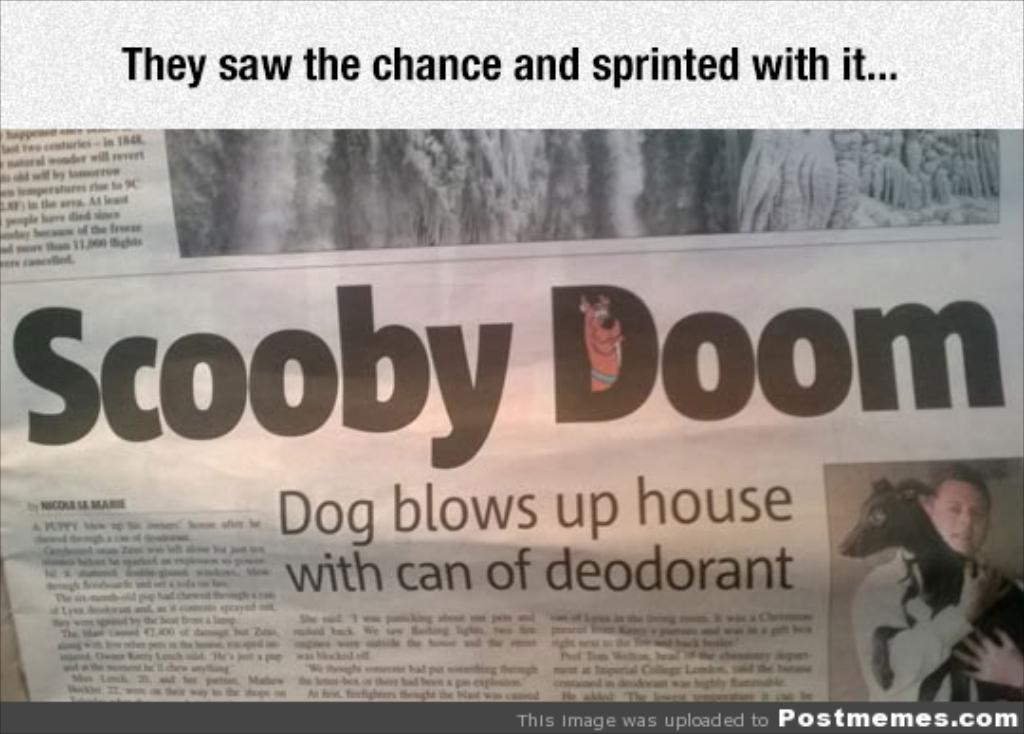What is the main subject in the center of the image? There is a newspaper in the center of the image. What is happening with the newspaper in the image? A person is holding a dog on the newspaper. Can you describe the newspaper in the image? There is writing on the newspaper. What type of chain can be seen connecting the dog to the newspaper? There is no chain present in the image; the dog is simply being held on the newspaper by a person. What stage of development is the beast currently in, as seen in the image? There is no beast present in the image; it features a person holding a dog on a newspaper. 